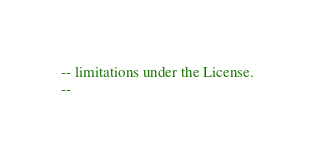<code> <loc_0><loc_0><loc_500><loc_500><_SQL_>-- limitations under the License.
--
</code> 